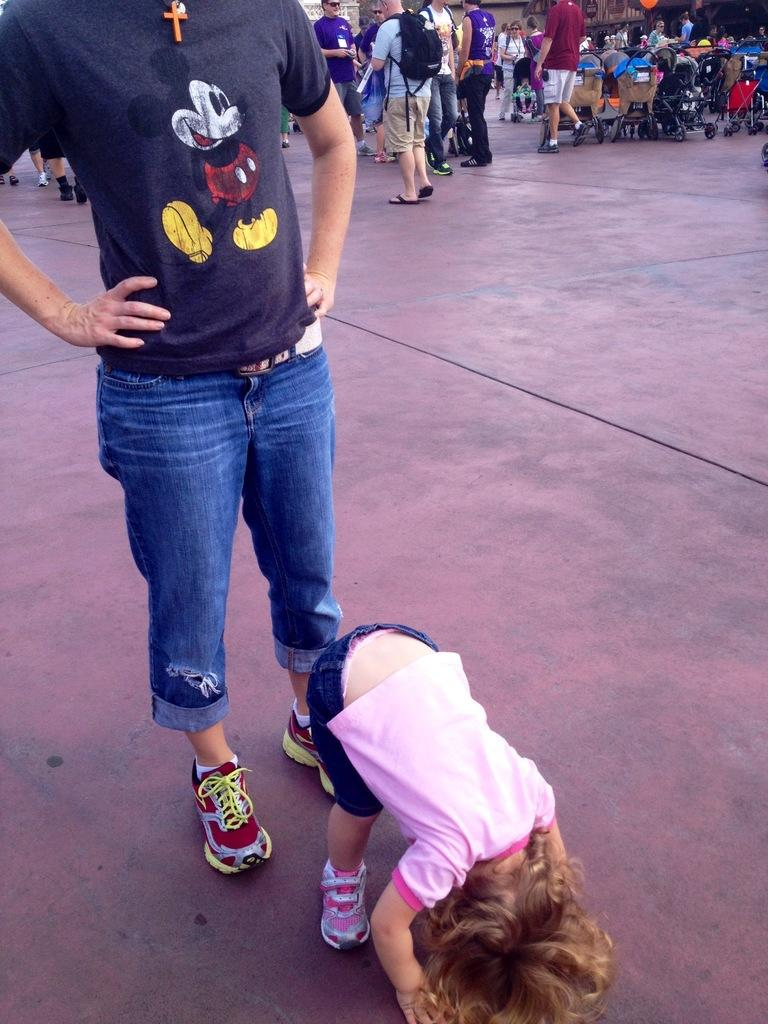How many people are in the image? There are people in the image, but the exact number is not specified. What is the child doing in the image? The child is bending in the image. What can be seen on the ground in the image? The ground is visible in the image, and there is a baby trolley on the ground. Can you see a tiger playing with the baby trolley in the image? No, there is no tiger present in the image. 